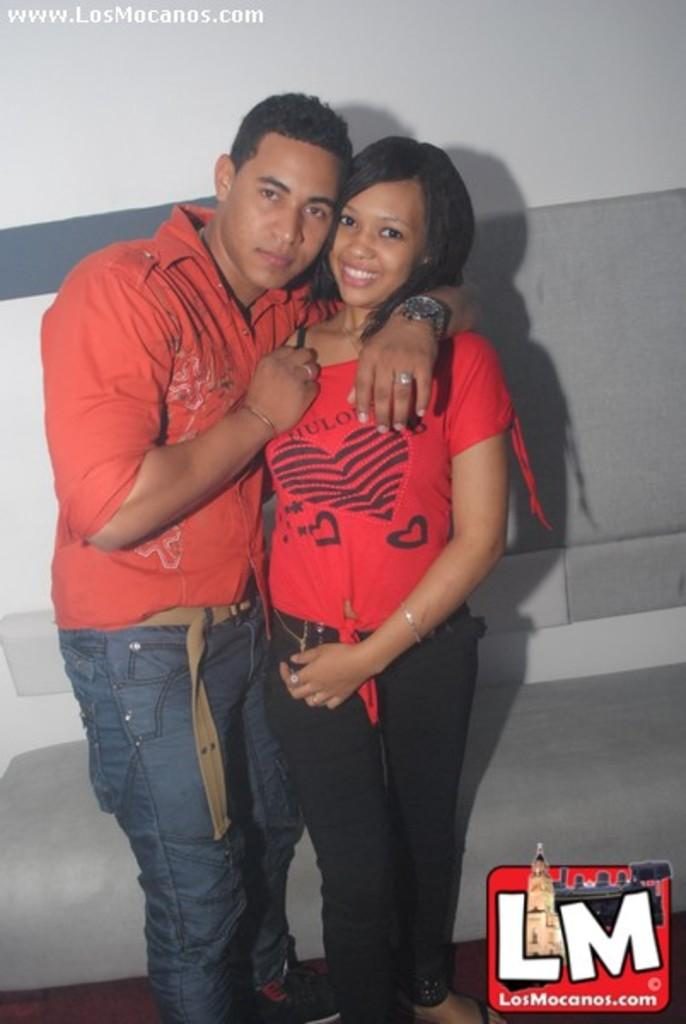How many people are in the image? There are two people in the image, a man and a woman. What are the man and woman doing in the image? Both the man and woman are standing. Can you describe any accessories the man is wearing in the image? The man is wearing a wrist watch, a finger ring, and a bracelet. What type of background can be seen in the image? There is a wall and a floor in the image. How many brass cows are present in the image? There are no brass cows present in the image. What is the rate of expansion of the wall in the image? The image does not provide information about the rate of expansion of the wall, as it is a static photograph. 